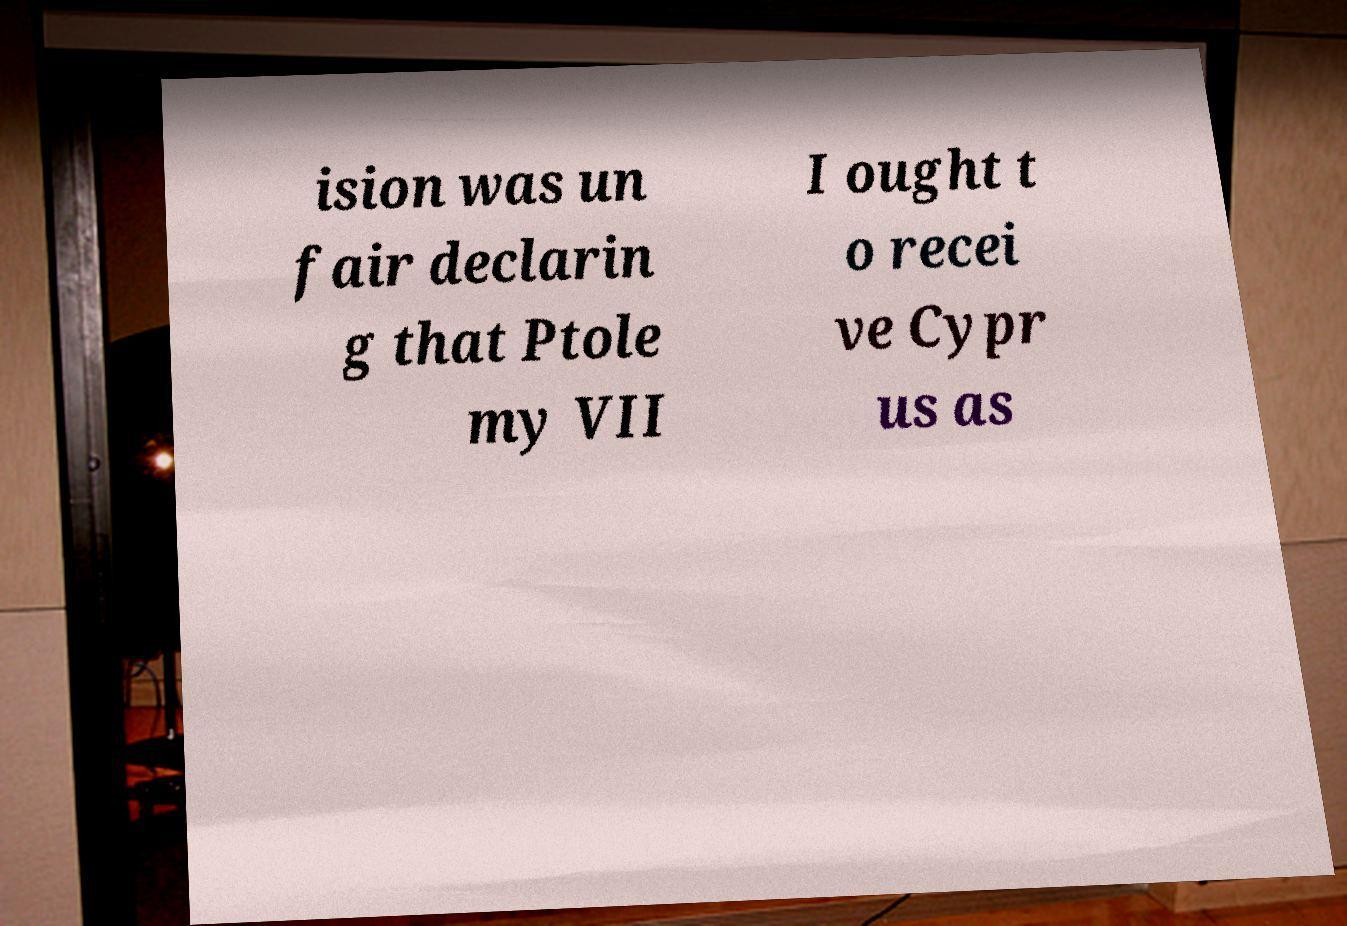Could you extract and type out the text from this image? ision was un fair declarin g that Ptole my VII I ought t o recei ve Cypr us as 